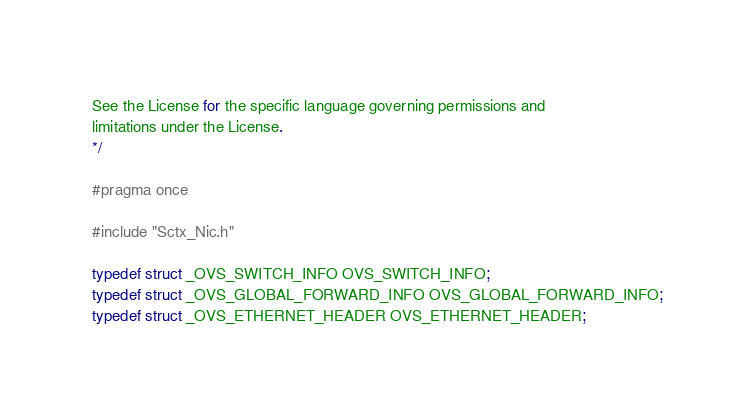<code> <loc_0><loc_0><loc_500><loc_500><_C_>See the License for the specific language governing permissions and
limitations under the License.
*/

#pragma once

#include "Sctx_Nic.h"

typedef struct _OVS_SWITCH_INFO OVS_SWITCH_INFO;
typedef struct _OVS_GLOBAL_FORWARD_INFO OVS_GLOBAL_FORWARD_INFO;
typedef struct _OVS_ETHERNET_HEADER OVS_ETHERNET_HEADER;
</code> 